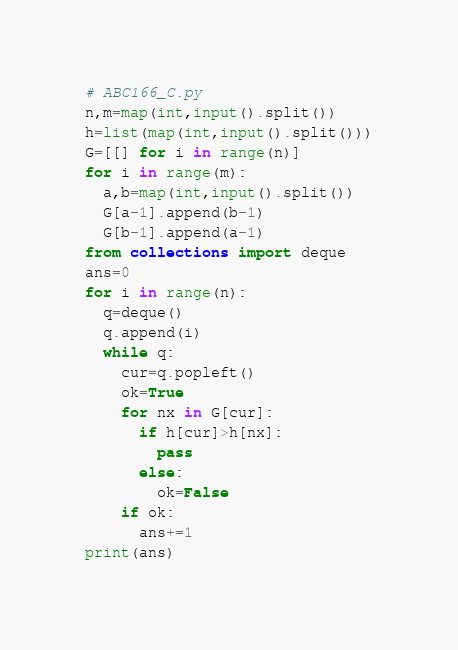Convert code to text. <code><loc_0><loc_0><loc_500><loc_500><_Python_># ABC166_C.py
n,m=map(int,input().split())
h=list(map(int,input().split()))
G=[[] for i in range(n)]
for i in range(m):
  a,b=map(int,input().split())
  G[a-1].append(b-1)
  G[b-1].append(a-1)
from collections import deque
ans=0
for i in range(n):
  q=deque()
  q.append(i)
  while q:
    cur=q.popleft()
    ok=True
    for nx in G[cur]:
      if h[cur]>h[nx]:
        pass
      else:
        ok=False
    if ok:
      ans+=1
print(ans)


</code> 